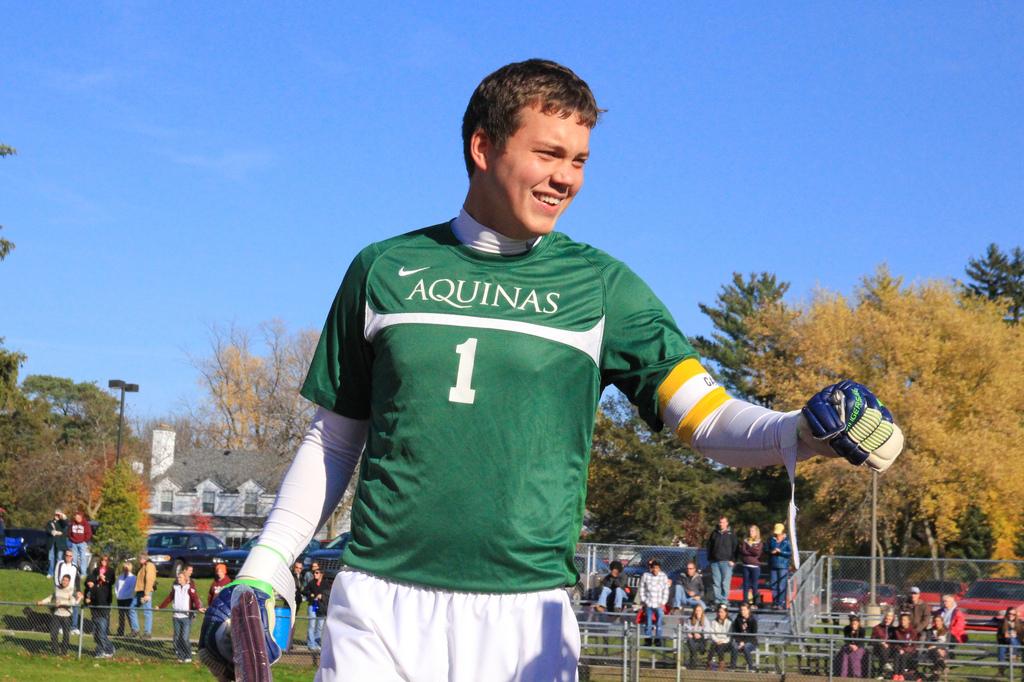What is the name of the team?
Provide a short and direct response. Aquinas. What is the man's number on the team?
Provide a succinct answer. 1. 